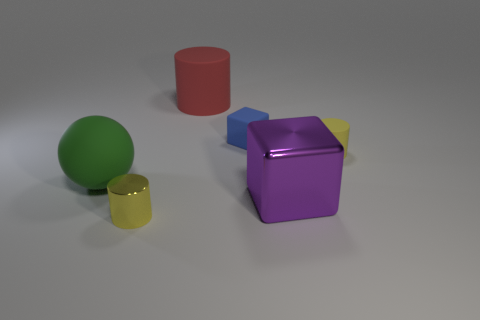What material is the block that is the same size as the green rubber object?
Make the answer very short. Metal. The small yellow object that is made of the same material as the purple thing is what shape?
Give a very brief answer. Cylinder. Are there fewer large shiny cubes than tiny brown metallic things?
Provide a succinct answer. No. There is a thing that is both in front of the small yellow rubber thing and to the right of the small matte cube; what material is it?
Offer a very short reply. Metal. There is a green matte object to the left of the tiny cylinder that is to the left of the matte cylinder that is in front of the red rubber thing; what is its size?
Offer a very short reply. Large. There is a big purple metal thing; is it the same shape as the tiny matte thing that is on the left side of the big metal cube?
Offer a terse response. Yes. What number of cylinders are both left of the blue thing and behind the green rubber thing?
Your answer should be compact. 1. How many cyan objects are either small cubes or big matte cylinders?
Keep it short and to the point. 0. Do the cube behind the matte sphere and the tiny cylinder that is on the right side of the red rubber thing have the same color?
Provide a short and direct response. No. The large matte object that is on the left side of the large matte cylinder that is to the right of the object that is in front of the large block is what color?
Make the answer very short. Green. 